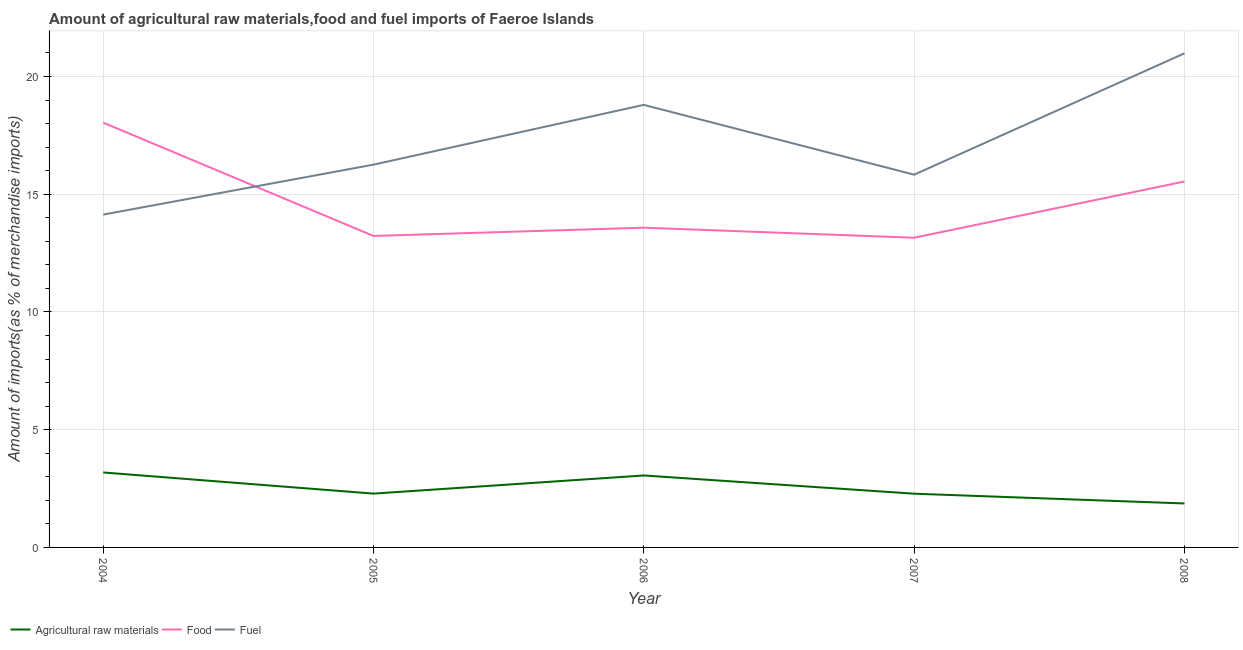How many different coloured lines are there?
Provide a short and direct response. 3. Does the line corresponding to percentage of food imports intersect with the line corresponding to percentage of raw materials imports?
Your response must be concise. No. Is the number of lines equal to the number of legend labels?
Provide a succinct answer. Yes. What is the percentage of food imports in 2005?
Offer a terse response. 13.23. Across all years, what is the maximum percentage of fuel imports?
Give a very brief answer. 20.98. Across all years, what is the minimum percentage of fuel imports?
Your response must be concise. 14.13. In which year was the percentage of food imports maximum?
Give a very brief answer. 2004. What is the total percentage of food imports in the graph?
Your answer should be very brief. 73.53. What is the difference between the percentage of food imports in 2004 and that in 2007?
Keep it short and to the point. 4.89. What is the difference between the percentage of fuel imports in 2008 and the percentage of food imports in 2007?
Your answer should be compact. 7.83. What is the average percentage of fuel imports per year?
Your response must be concise. 17.2. In the year 2007, what is the difference between the percentage of fuel imports and percentage of food imports?
Your answer should be very brief. 2.68. What is the ratio of the percentage of fuel imports in 2004 to that in 2008?
Keep it short and to the point. 0.67. Is the percentage of fuel imports in 2004 less than that in 2006?
Give a very brief answer. Yes. What is the difference between the highest and the second highest percentage of raw materials imports?
Provide a succinct answer. 0.13. What is the difference between the highest and the lowest percentage of raw materials imports?
Ensure brevity in your answer.  1.32. In how many years, is the percentage of food imports greater than the average percentage of food imports taken over all years?
Your response must be concise. 2. Is the sum of the percentage of raw materials imports in 2004 and 2006 greater than the maximum percentage of fuel imports across all years?
Ensure brevity in your answer.  No. Is it the case that in every year, the sum of the percentage of raw materials imports and percentage of food imports is greater than the percentage of fuel imports?
Keep it short and to the point. No. Does the percentage of food imports monotonically increase over the years?
Offer a terse response. No. Is the percentage of food imports strictly greater than the percentage of fuel imports over the years?
Your answer should be compact. No. Is the percentage of food imports strictly less than the percentage of fuel imports over the years?
Provide a short and direct response. No. How many lines are there?
Give a very brief answer. 3. How many years are there in the graph?
Ensure brevity in your answer.  5. What is the difference between two consecutive major ticks on the Y-axis?
Give a very brief answer. 5. Does the graph contain grids?
Keep it short and to the point. Yes. Where does the legend appear in the graph?
Your answer should be very brief. Bottom left. How are the legend labels stacked?
Keep it short and to the point. Horizontal. What is the title of the graph?
Your response must be concise. Amount of agricultural raw materials,food and fuel imports of Faeroe Islands. Does "Non-communicable diseases" appear as one of the legend labels in the graph?
Your answer should be compact. No. What is the label or title of the Y-axis?
Keep it short and to the point. Amount of imports(as % of merchandise imports). What is the Amount of imports(as % of merchandise imports) in Agricultural raw materials in 2004?
Offer a very short reply. 3.18. What is the Amount of imports(as % of merchandise imports) of Food in 2004?
Give a very brief answer. 18.04. What is the Amount of imports(as % of merchandise imports) of Fuel in 2004?
Make the answer very short. 14.13. What is the Amount of imports(as % of merchandise imports) of Agricultural raw materials in 2005?
Your answer should be very brief. 2.29. What is the Amount of imports(as % of merchandise imports) in Food in 2005?
Keep it short and to the point. 13.23. What is the Amount of imports(as % of merchandise imports) of Fuel in 2005?
Your answer should be very brief. 16.25. What is the Amount of imports(as % of merchandise imports) of Agricultural raw materials in 2006?
Your answer should be compact. 3.06. What is the Amount of imports(as % of merchandise imports) of Food in 2006?
Your response must be concise. 13.58. What is the Amount of imports(as % of merchandise imports) in Fuel in 2006?
Give a very brief answer. 18.79. What is the Amount of imports(as % of merchandise imports) of Agricultural raw materials in 2007?
Make the answer very short. 2.28. What is the Amount of imports(as % of merchandise imports) in Food in 2007?
Your answer should be compact. 13.15. What is the Amount of imports(as % of merchandise imports) of Fuel in 2007?
Ensure brevity in your answer.  15.83. What is the Amount of imports(as % of merchandise imports) in Agricultural raw materials in 2008?
Your answer should be compact. 1.87. What is the Amount of imports(as % of merchandise imports) in Food in 2008?
Make the answer very short. 15.54. What is the Amount of imports(as % of merchandise imports) in Fuel in 2008?
Offer a very short reply. 20.98. Across all years, what is the maximum Amount of imports(as % of merchandise imports) in Agricultural raw materials?
Your answer should be compact. 3.18. Across all years, what is the maximum Amount of imports(as % of merchandise imports) of Food?
Keep it short and to the point. 18.04. Across all years, what is the maximum Amount of imports(as % of merchandise imports) of Fuel?
Your response must be concise. 20.98. Across all years, what is the minimum Amount of imports(as % of merchandise imports) of Agricultural raw materials?
Your answer should be very brief. 1.87. Across all years, what is the minimum Amount of imports(as % of merchandise imports) of Food?
Provide a short and direct response. 13.15. Across all years, what is the minimum Amount of imports(as % of merchandise imports) of Fuel?
Provide a short and direct response. 14.13. What is the total Amount of imports(as % of merchandise imports) of Agricultural raw materials in the graph?
Keep it short and to the point. 12.67. What is the total Amount of imports(as % of merchandise imports) of Food in the graph?
Provide a succinct answer. 73.53. What is the total Amount of imports(as % of merchandise imports) of Fuel in the graph?
Ensure brevity in your answer.  85.99. What is the difference between the Amount of imports(as % of merchandise imports) in Agricultural raw materials in 2004 and that in 2005?
Your response must be concise. 0.9. What is the difference between the Amount of imports(as % of merchandise imports) in Food in 2004 and that in 2005?
Ensure brevity in your answer.  4.81. What is the difference between the Amount of imports(as % of merchandise imports) in Fuel in 2004 and that in 2005?
Provide a succinct answer. -2.12. What is the difference between the Amount of imports(as % of merchandise imports) of Agricultural raw materials in 2004 and that in 2006?
Offer a terse response. 0.13. What is the difference between the Amount of imports(as % of merchandise imports) in Food in 2004 and that in 2006?
Offer a terse response. 4.46. What is the difference between the Amount of imports(as % of merchandise imports) of Fuel in 2004 and that in 2006?
Offer a terse response. -4.66. What is the difference between the Amount of imports(as % of merchandise imports) of Agricultural raw materials in 2004 and that in 2007?
Give a very brief answer. 0.9. What is the difference between the Amount of imports(as % of merchandise imports) of Food in 2004 and that in 2007?
Provide a succinct answer. 4.89. What is the difference between the Amount of imports(as % of merchandise imports) in Fuel in 2004 and that in 2007?
Offer a terse response. -1.7. What is the difference between the Amount of imports(as % of merchandise imports) of Agricultural raw materials in 2004 and that in 2008?
Your answer should be very brief. 1.32. What is the difference between the Amount of imports(as % of merchandise imports) in Fuel in 2004 and that in 2008?
Your answer should be compact. -6.85. What is the difference between the Amount of imports(as % of merchandise imports) in Agricultural raw materials in 2005 and that in 2006?
Provide a short and direct response. -0.77. What is the difference between the Amount of imports(as % of merchandise imports) in Food in 2005 and that in 2006?
Your answer should be compact. -0.35. What is the difference between the Amount of imports(as % of merchandise imports) in Fuel in 2005 and that in 2006?
Ensure brevity in your answer.  -2.54. What is the difference between the Amount of imports(as % of merchandise imports) in Agricultural raw materials in 2005 and that in 2007?
Offer a very short reply. 0. What is the difference between the Amount of imports(as % of merchandise imports) in Food in 2005 and that in 2007?
Your response must be concise. 0.08. What is the difference between the Amount of imports(as % of merchandise imports) of Fuel in 2005 and that in 2007?
Give a very brief answer. 0.43. What is the difference between the Amount of imports(as % of merchandise imports) of Agricultural raw materials in 2005 and that in 2008?
Your response must be concise. 0.42. What is the difference between the Amount of imports(as % of merchandise imports) of Food in 2005 and that in 2008?
Provide a short and direct response. -2.31. What is the difference between the Amount of imports(as % of merchandise imports) of Fuel in 2005 and that in 2008?
Ensure brevity in your answer.  -4.73. What is the difference between the Amount of imports(as % of merchandise imports) of Agricultural raw materials in 2006 and that in 2007?
Your answer should be compact. 0.77. What is the difference between the Amount of imports(as % of merchandise imports) of Food in 2006 and that in 2007?
Your response must be concise. 0.43. What is the difference between the Amount of imports(as % of merchandise imports) in Fuel in 2006 and that in 2007?
Provide a succinct answer. 2.96. What is the difference between the Amount of imports(as % of merchandise imports) in Agricultural raw materials in 2006 and that in 2008?
Provide a succinct answer. 1.19. What is the difference between the Amount of imports(as % of merchandise imports) of Food in 2006 and that in 2008?
Provide a short and direct response. -1.96. What is the difference between the Amount of imports(as % of merchandise imports) of Fuel in 2006 and that in 2008?
Give a very brief answer. -2.19. What is the difference between the Amount of imports(as % of merchandise imports) of Agricultural raw materials in 2007 and that in 2008?
Keep it short and to the point. 0.42. What is the difference between the Amount of imports(as % of merchandise imports) of Food in 2007 and that in 2008?
Keep it short and to the point. -2.39. What is the difference between the Amount of imports(as % of merchandise imports) in Fuel in 2007 and that in 2008?
Offer a very short reply. -5.15. What is the difference between the Amount of imports(as % of merchandise imports) in Agricultural raw materials in 2004 and the Amount of imports(as % of merchandise imports) in Food in 2005?
Offer a terse response. -10.04. What is the difference between the Amount of imports(as % of merchandise imports) of Agricultural raw materials in 2004 and the Amount of imports(as % of merchandise imports) of Fuel in 2005?
Offer a very short reply. -13.07. What is the difference between the Amount of imports(as % of merchandise imports) of Food in 2004 and the Amount of imports(as % of merchandise imports) of Fuel in 2005?
Keep it short and to the point. 1.78. What is the difference between the Amount of imports(as % of merchandise imports) in Agricultural raw materials in 2004 and the Amount of imports(as % of merchandise imports) in Food in 2006?
Provide a short and direct response. -10.39. What is the difference between the Amount of imports(as % of merchandise imports) of Agricultural raw materials in 2004 and the Amount of imports(as % of merchandise imports) of Fuel in 2006?
Make the answer very short. -15.61. What is the difference between the Amount of imports(as % of merchandise imports) in Food in 2004 and the Amount of imports(as % of merchandise imports) in Fuel in 2006?
Your answer should be compact. -0.75. What is the difference between the Amount of imports(as % of merchandise imports) of Agricultural raw materials in 2004 and the Amount of imports(as % of merchandise imports) of Food in 2007?
Offer a very short reply. -9.97. What is the difference between the Amount of imports(as % of merchandise imports) of Agricultural raw materials in 2004 and the Amount of imports(as % of merchandise imports) of Fuel in 2007?
Your answer should be compact. -12.65. What is the difference between the Amount of imports(as % of merchandise imports) of Food in 2004 and the Amount of imports(as % of merchandise imports) of Fuel in 2007?
Your answer should be very brief. 2.21. What is the difference between the Amount of imports(as % of merchandise imports) of Agricultural raw materials in 2004 and the Amount of imports(as % of merchandise imports) of Food in 2008?
Your response must be concise. -12.36. What is the difference between the Amount of imports(as % of merchandise imports) of Agricultural raw materials in 2004 and the Amount of imports(as % of merchandise imports) of Fuel in 2008?
Your answer should be compact. -17.8. What is the difference between the Amount of imports(as % of merchandise imports) in Food in 2004 and the Amount of imports(as % of merchandise imports) in Fuel in 2008?
Your response must be concise. -2.94. What is the difference between the Amount of imports(as % of merchandise imports) in Agricultural raw materials in 2005 and the Amount of imports(as % of merchandise imports) in Food in 2006?
Give a very brief answer. -11.29. What is the difference between the Amount of imports(as % of merchandise imports) of Agricultural raw materials in 2005 and the Amount of imports(as % of merchandise imports) of Fuel in 2006?
Provide a succinct answer. -16.51. What is the difference between the Amount of imports(as % of merchandise imports) of Food in 2005 and the Amount of imports(as % of merchandise imports) of Fuel in 2006?
Give a very brief answer. -5.57. What is the difference between the Amount of imports(as % of merchandise imports) of Agricultural raw materials in 2005 and the Amount of imports(as % of merchandise imports) of Food in 2007?
Keep it short and to the point. -10.87. What is the difference between the Amount of imports(as % of merchandise imports) of Agricultural raw materials in 2005 and the Amount of imports(as % of merchandise imports) of Fuel in 2007?
Your response must be concise. -13.54. What is the difference between the Amount of imports(as % of merchandise imports) in Food in 2005 and the Amount of imports(as % of merchandise imports) in Fuel in 2007?
Your answer should be very brief. -2.6. What is the difference between the Amount of imports(as % of merchandise imports) of Agricultural raw materials in 2005 and the Amount of imports(as % of merchandise imports) of Food in 2008?
Your response must be concise. -13.25. What is the difference between the Amount of imports(as % of merchandise imports) in Agricultural raw materials in 2005 and the Amount of imports(as % of merchandise imports) in Fuel in 2008?
Keep it short and to the point. -18.7. What is the difference between the Amount of imports(as % of merchandise imports) in Food in 2005 and the Amount of imports(as % of merchandise imports) in Fuel in 2008?
Make the answer very short. -7.76. What is the difference between the Amount of imports(as % of merchandise imports) of Agricultural raw materials in 2006 and the Amount of imports(as % of merchandise imports) of Food in 2007?
Your response must be concise. -10.1. What is the difference between the Amount of imports(as % of merchandise imports) in Agricultural raw materials in 2006 and the Amount of imports(as % of merchandise imports) in Fuel in 2007?
Your answer should be very brief. -12.77. What is the difference between the Amount of imports(as % of merchandise imports) in Food in 2006 and the Amount of imports(as % of merchandise imports) in Fuel in 2007?
Your answer should be compact. -2.25. What is the difference between the Amount of imports(as % of merchandise imports) in Agricultural raw materials in 2006 and the Amount of imports(as % of merchandise imports) in Food in 2008?
Your response must be concise. -12.48. What is the difference between the Amount of imports(as % of merchandise imports) in Agricultural raw materials in 2006 and the Amount of imports(as % of merchandise imports) in Fuel in 2008?
Make the answer very short. -17.93. What is the difference between the Amount of imports(as % of merchandise imports) of Food in 2006 and the Amount of imports(as % of merchandise imports) of Fuel in 2008?
Ensure brevity in your answer.  -7.4. What is the difference between the Amount of imports(as % of merchandise imports) in Agricultural raw materials in 2007 and the Amount of imports(as % of merchandise imports) in Food in 2008?
Keep it short and to the point. -13.26. What is the difference between the Amount of imports(as % of merchandise imports) of Agricultural raw materials in 2007 and the Amount of imports(as % of merchandise imports) of Fuel in 2008?
Your answer should be very brief. -18.7. What is the difference between the Amount of imports(as % of merchandise imports) of Food in 2007 and the Amount of imports(as % of merchandise imports) of Fuel in 2008?
Your response must be concise. -7.83. What is the average Amount of imports(as % of merchandise imports) in Agricultural raw materials per year?
Offer a terse response. 2.53. What is the average Amount of imports(as % of merchandise imports) of Food per year?
Your answer should be compact. 14.71. What is the average Amount of imports(as % of merchandise imports) of Fuel per year?
Your response must be concise. 17.2. In the year 2004, what is the difference between the Amount of imports(as % of merchandise imports) of Agricultural raw materials and Amount of imports(as % of merchandise imports) of Food?
Your response must be concise. -14.86. In the year 2004, what is the difference between the Amount of imports(as % of merchandise imports) in Agricultural raw materials and Amount of imports(as % of merchandise imports) in Fuel?
Your answer should be very brief. -10.95. In the year 2004, what is the difference between the Amount of imports(as % of merchandise imports) in Food and Amount of imports(as % of merchandise imports) in Fuel?
Give a very brief answer. 3.91. In the year 2005, what is the difference between the Amount of imports(as % of merchandise imports) in Agricultural raw materials and Amount of imports(as % of merchandise imports) in Food?
Keep it short and to the point. -10.94. In the year 2005, what is the difference between the Amount of imports(as % of merchandise imports) in Agricultural raw materials and Amount of imports(as % of merchandise imports) in Fuel?
Offer a terse response. -13.97. In the year 2005, what is the difference between the Amount of imports(as % of merchandise imports) in Food and Amount of imports(as % of merchandise imports) in Fuel?
Your answer should be very brief. -3.03. In the year 2006, what is the difference between the Amount of imports(as % of merchandise imports) of Agricultural raw materials and Amount of imports(as % of merchandise imports) of Food?
Provide a succinct answer. -10.52. In the year 2006, what is the difference between the Amount of imports(as % of merchandise imports) of Agricultural raw materials and Amount of imports(as % of merchandise imports) of Fuel?
Make the answer very short. -15.74. In the year 2006, what is the difference between the Amount of imports(as % of merchandise imports) of Food and Amount of imports(as % of merchandise imports) of Fuel?
Your answer should be very brief. -5.22. In the year 2007, what is the difference between the Amount of imports(as % of merchandise imports) of Agricultural raw materials and Amount of imports(as % of merchandise imports) of Food?
Offer a very short reply. -10.87. In the year 2007, what is the difference between the Amount of imports(as % of merchandise imports) of Agricultural raw materials and Amount of imports(as % of merchandise imports) of Fuel?
Your answer should be very brief. -13.55. In the year 2007, what is the difference between the Amount of imports(as % of merchandise imports) of Food and Amount of imports(as % of merchandise imports) of Fuel?
Your response must be concise. -2.68. In the year 2008, what is the difference between the Amount of imports(as % of merchandise imports) of Agricultural raw materials and Amount of imports(as % of merchandise imports) of Food?
Offer a very short reply. -13.67. In the year 2008, what is the difference between the Amount of imports(as % of merchandise imports) of Agricultural raw materials and Amount of imports(as % of merchandise imports) of Fuel?
Make the answer very short. -19.12. In the year 2008, what is the difference between the Amount of imports(as % of merchandise imports) of Food and Amount of imports(as % of merchandise imports) of Fuel?
Keep it short and to the point. -5.44. What is the ratio of the Amount of imports(as % of merchandise imports) of Agricultural raw materials in 2004 to that in 2005?
Your response must be concise. 1.39. What is the ratio of the Amount of imports(as % of merchandise imports) of Food in 2004 to that in 2005?
Ensure brevity in your answer.  1.36. What is the ratio of the Amount of imports(as % of merchandise imports) in Fuel in 2004 to that in 2005?
Your answer should be very brief. 0.87. What is the ratio of the Amount of imports(as % of merchandise imports) in Agricultural raw materials in 2004 to that in 2006?
Ensure brevity in your answer.  1.04. What is the ratio of the Amount of imports(as % of merchandise imports) of Food in 2004 to that in 2006?
Your response must be concise. 1.33. What is the ratio of the Amount of imports(as % of merchandise imports) in Fuel in 2004 to that in 2006?
Your answer should be compact. 0.75. What is the ratio of the Amount of imports(as % of merchandise imports) of Agricultural raw materials in 2004 to that in 2007?
Provide a short and direct response. 1.39. What is the ratio of the Amount of imports(as % of merchandise imports) in Food in 2004 to that in 2007?
Offer a very short reply. 1.37. What is the ratio of the Amount of imports(as % of merchandise imports) of Fuel in 2004 to that in 2007?
Make the answer very short. 0.89. What is the ratio of the Amount of imports(as % of merchandise imports) in Agricultural raw materials in 2004 to that in 2008?
Offer a terse response. 1.71. What is the ratio of the Amount of imports(as % of merchandise imports) in Food in 2004 to that in 2008?
Give a very brief answer. 1.16. What is the ratio of the Amount of imports(as % of merchandise imports) of Fuel in 2004 to that in 2008?
Offer a very short reply. 0.67. What is the ratio of the Amount of imports(as % of merchandise imports) in Agricultural raw materials in 2005 to that in 2006?
Give a very brief answer. 0.75. What is the ratio of the Amount of imports(as % of merchandise imports) of Food in 2005 to that in 2006?
Your answer should be very brief. 0.97. What is the ratio of the Amount of imports(as % of merchandise imports) of Fuel in 2005 to that in 2006?
Offer a very short reply. 0.86. What is the ratio of the Amount of imports(as % of merchandise imports) in Food in 2005 to that in 2007?
Your answer should be very brief. 1.01. What is the ratio of the Amount of imports(as % of merchandise imports) of Fuel in 2005 to that in 2007?
Keep it short and to the point. 1.03. What is the ratio of the Amount of imports(as % of merchandise imports) in Agricultural raw materials in 2005 to that in 2008?
Provide a succinct answer. 1.22. What is the ratio of the Amount of imports(as % of merchandise imports) of Food in 2005 to that in 2008?
Your answer should be compact. 0.85. What is the ratio of the Amount of imports(as % of merchandise imports) of Fuel in 2005 to that in 2008?
Provide a succinct answer. 0.77. What is the ratio of the Amount of imports(as % of merchandise imports) in Agricultural raw materials in 2006 to that in 2007?
Make the answer very short. 1.34. What is the ratio of the Amount of imports(as % of merchandise imports) of Food in 2006 to that in 2007?
Make the answer very short. 1.03. What is the ratio of the Amount of imports(as % of merchandise imports) in Fuel in 2006 to that in 2007?
Your response must be concise. 1.19. What is the ratio of the Amount of imports(as % of merchandise imports) of Agricultural raw materials in 2006 to that in 2008?
Provide a short and direct response. 1.64. What is the ratio of the Amount of imports(as % of merchandise imports) of Food in 2006 to that in 2008?
Keep it short and to the point. 0.87. What is the ratio of the Amount of imports(as % of merchandise imports) of Fuel in 2006 to that in 2008?
Give a very brief answer. 0.9. What is the ratio of the Amount of imports(as % of merchandise imports) in Agricultural raw materials in 2007 to that in 2008?
Your answer should be very brief. 1.22. What is the ratio of the Amount of imports(as % of merchandise imports) in Food in 2007 to that in 2008?
Make the answer very short. 0.85. What is the ratio of the Amount of imports(as % of merchandise imports) of Fuel in 2007 to that in 2008?
Provide a succinct answer. 0.75. What is the difference between the highest and the second highest Amount of imports(as % of merchandise imports) in Agricultural raw materials?
Your answer should be very brief. 0.13. What is the difference between the highest and the second highest Amount of imports(as % of merchandise imports) in Food?
Provide a succinct answer. 2.5. What is the difference between the highest and the second highest Amount of imports(as % of merchandise imports) in Fuel?
Your answer should be very brief. 2.19. What is the difference between the highest and the lowest Amount of imports(as % of merchandise imports) in Agricultural raw materials?
Offer a terse response. 1.32. What is the difference between the highest and the lowest Amount of imports(as % of merchandise imports) in Food?
Your answer should be very brief. 4.89. What is the difference between the highest and the lowest Amount of imports(as % of merchandise imports) in Fuel?
Your response must be concise. 6.85. 